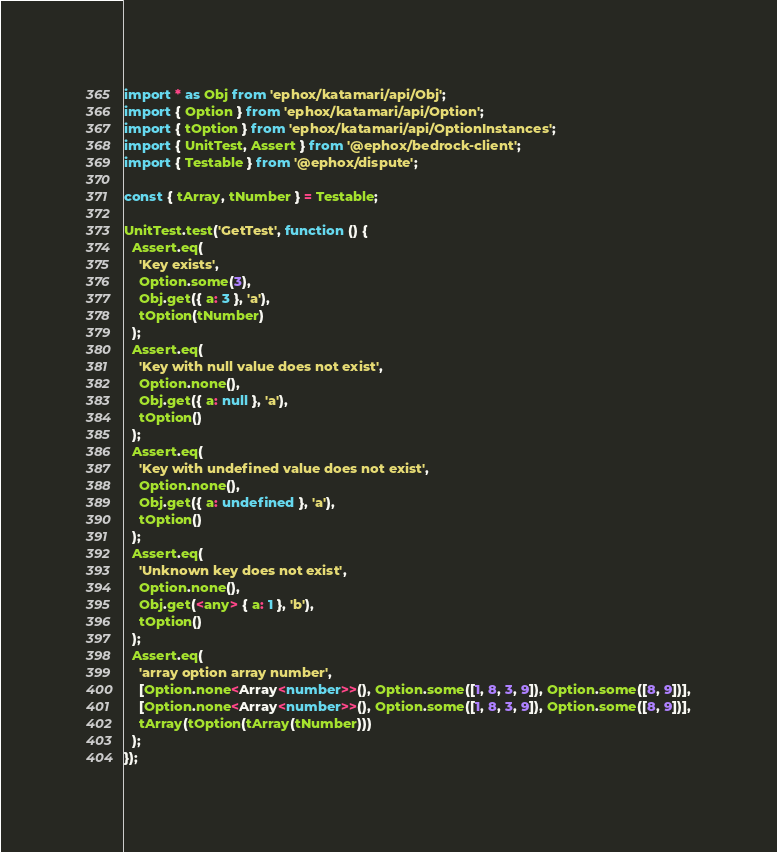<code> <loc_0><loc_0><loc_500><loc_500><_TypeScript_>import * as Obj from 'ephox/katamari/api/Obj';
import { Option } from 'ephox/katamari/api/Option';
import { tOption } from 'ephox/katamari/api/OptionInstances';
import { UnitTest, Assert } from '@ephox/bedrock-client';
import { Testable } from '@ephox/dispute';

const { tArray, tNumber } = Testable;

UnitTest.test('GetTest', function () {
  Assert.eq(
    'Key exists',
    Option.some(3),
    Obj.get({ a: 3 }, 'a'),
    tOption(tNumber)
  );
  Assert.eq(
    'Key with null value does not exist',
    Option.none(),
    Obj.get({ a: null }, 'a'),
    tOption()
  );
  Assert.eq(
    'Key with undefined value does not exist',
    Option.none(),
    Obj.get({ a: undefined }, 'a'),
    tOption()
  );
  Assert.eq(
    'Unknown key does not exist',
    Option.none(),
    Obj.get(<any> { a: 1 }, 'b'),
    tOption()
  );
  Assert.eq(
    'array option array number',
    [Option.none<Array<number>>(), Option.some([1, 8, 3, 9]), Option.some([8, 9])],
    [Option.none<Array<number>>(), Option.some([1, 8, 3, 9]), Option.some([8, 9])],
    tArray(tOption(tArray(tNumber)))
  );
});
</code> 